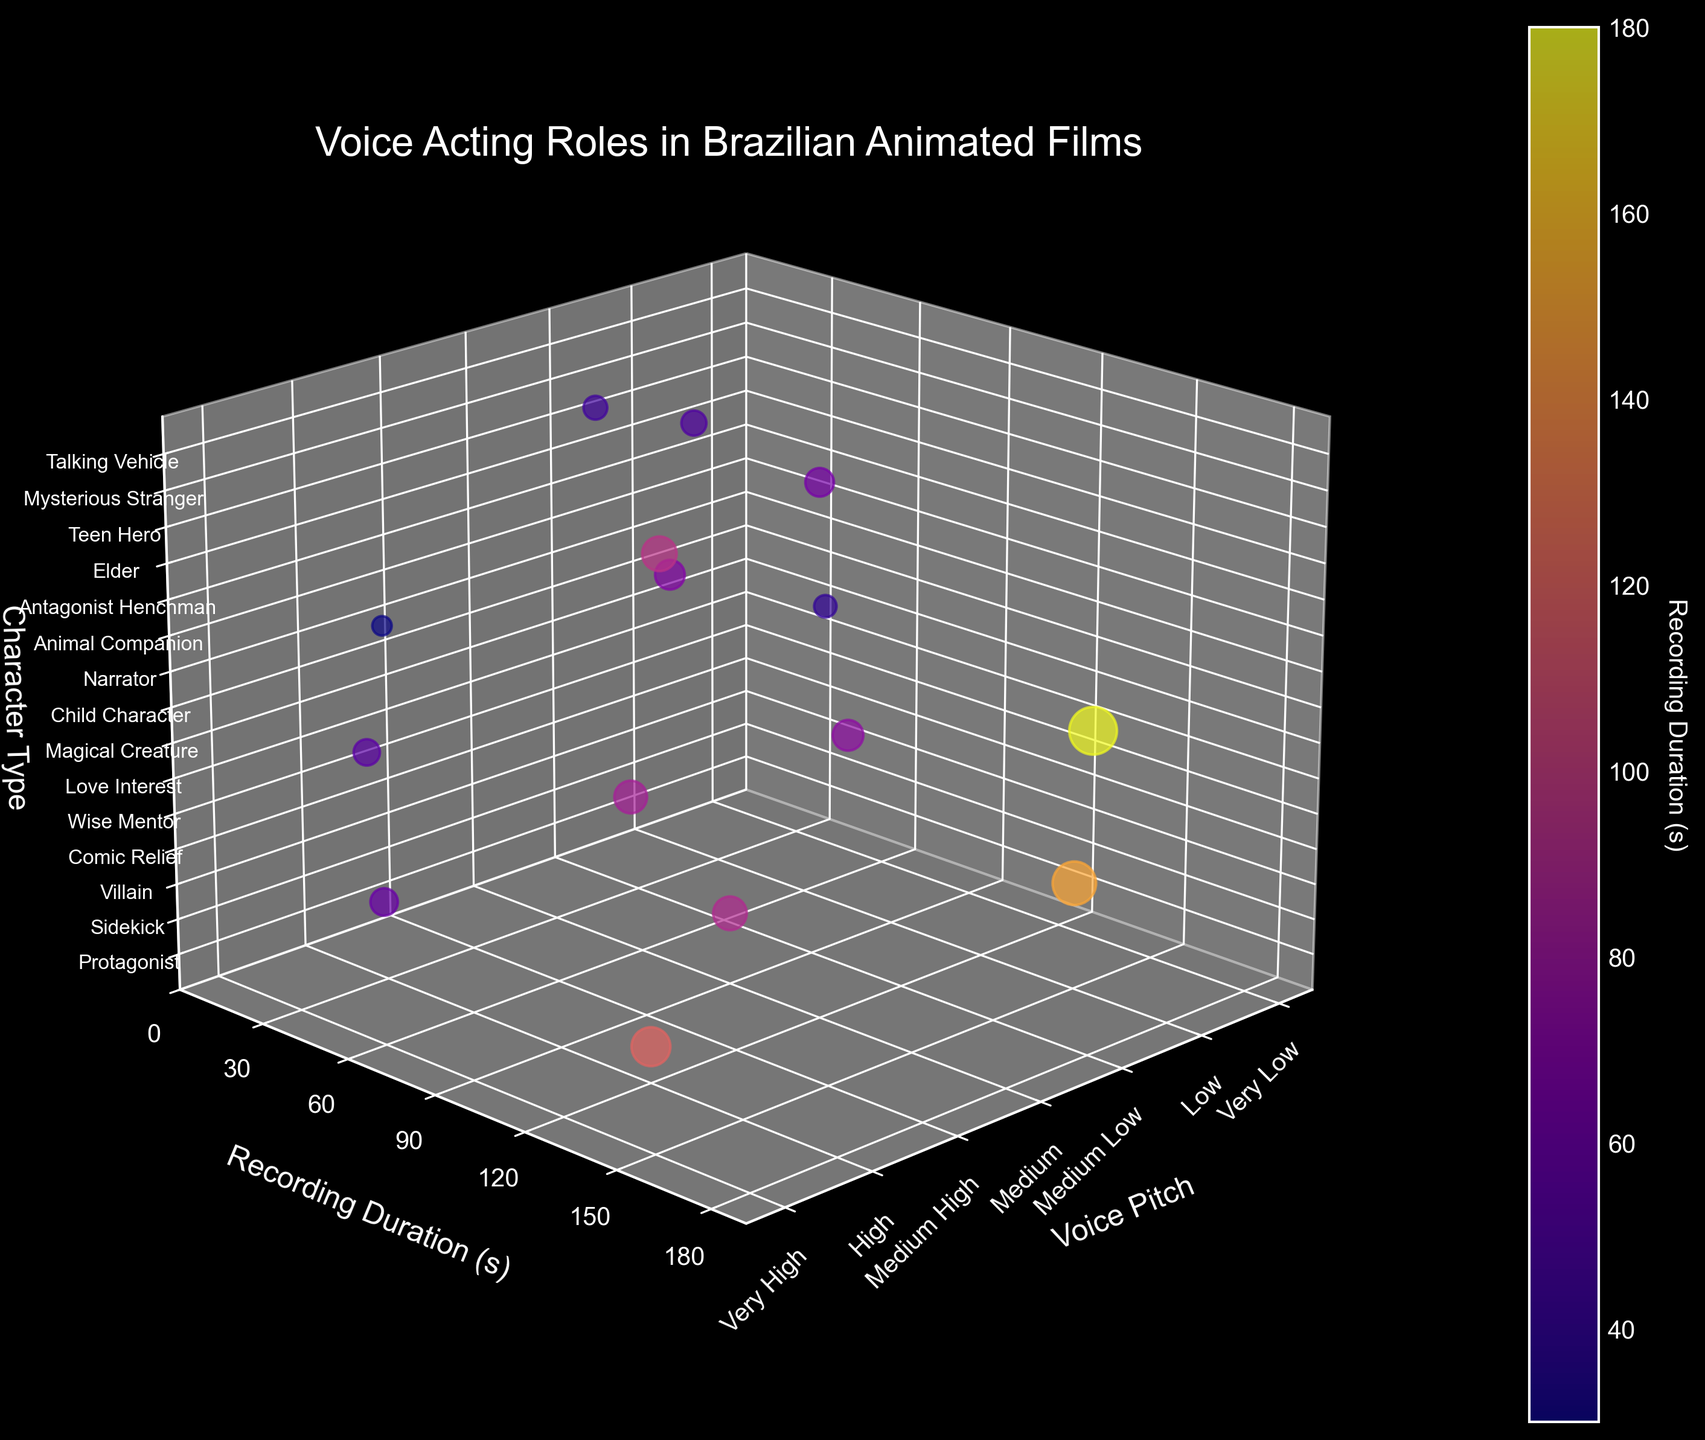what is the title of the plot? The title of a plot is usually found at the top of the figure and in this case, it reads "Voice Acting Roles in Brazilian Animated Films"
Answer: Voice Acting Roles in Brazilian Animated Films What are the labels of the three axes? The axis labels are located along the axes and describe what each axis represents: "Voice Pitch" for the x-axis, "Recording Duration (s)" for the y-axis, and "Character Type" for the z-axis.
Answer: Voice Pitch, Recording Duration (s), Character Type How many character types are depicted in the plot? The plot includes a unique data point for each character type, marked on the z-axis. Counting these labels will give the total number.
Answer: 15 Which character type has the longest recording duration? By checking the data points and labels for the y-axis (Recording Duration), the character with the highest value is the one with the longest recording duration.
Answer: Narrator What is the voice pitch for the character "Protagonist"? Locate the "Protagonist" label along the z-axis and trace the corresponding data point to the x-axis labeled for voice pitch.
Answer: High What is the average recording duration for characters with Medium and Medium High voice pitch? Identify and record the durations for characters with Medium (90s, 70s, 45s) and Medium High (85s, 95s) voice pitches, then compute their average: (90 + 70 + 45) / 3 for Medium and (85 + 95) / 2 for Medium High.
Answer: Medium: 68.33, Medium High: 90 Which character types have a voice pitch of "Very High"? Locate the data points on the x-axis labeled "Very High" and refer to the z-axis to find the corresponding character types.
Answer: Comic Relief, Child Character Which characters have recording durations less than 50 seconds? Look at the y-axis to find data points below 50 seconds and check the z-axis for the corresponding character types.
Answer: Magical Creature, Mysterious Stranger, Animal Companion What is the difference in recording duration between "Villain" and "Animal Companion"? Find the recording durations for "Villain" (150s) and "Animal Companion" (30s), then subtract to find the difference: 150 - 30.
Answer: 120 Which character types have a voice pitch labeled as "Low"? Identify the data points on the x-axis at "Low" and refer to the z-axis for the corresponding character types.
Answer: Villain, Wise Mentor, Elder 